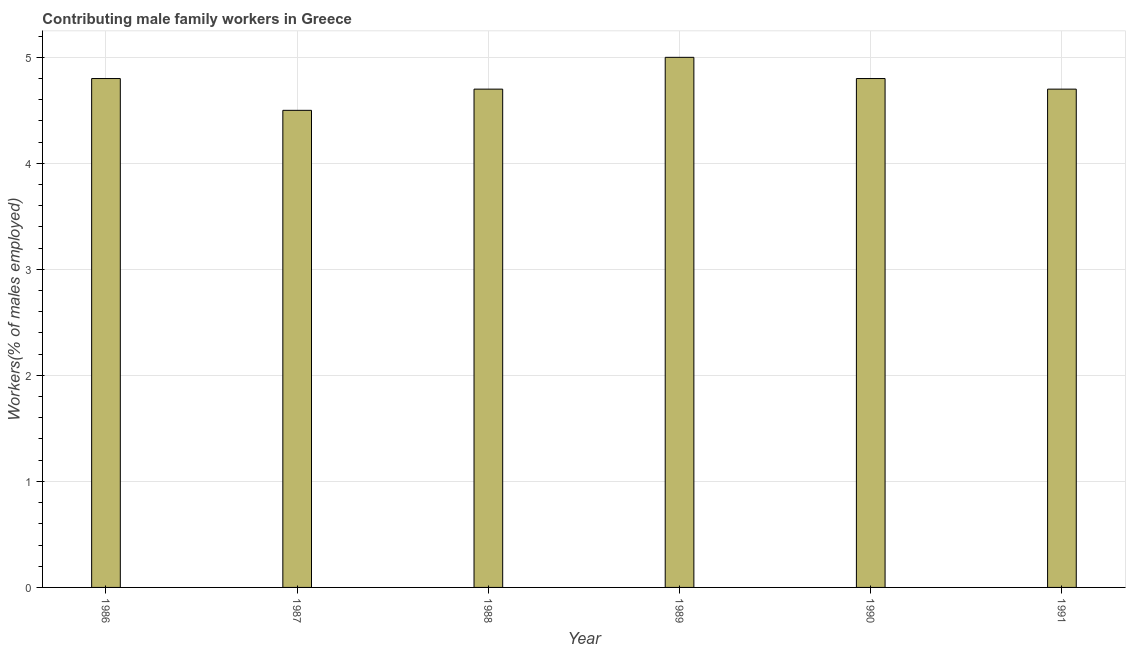What is the title of the graph?
Offer a terse response. Contributing male family workers in Greece. What is the label or title of the Y-axis?
Your answer should be compact. Workers(% of males employed). What is the contributing male family workers in 1988?
Offer a terse response. 4.7. Across all years, what is the maximum contributing male family workers?
Offer a terse response. 5. What is the sum of the contributing male family workers?
Make the answer very short. 28.5. What is the difference between the contributing male family workers in 1988 and 1991?
Provide a succinct answer. 0. What is the average contributing male family workers per year?
Provide a short and direct response. 4.75. What is the median contributing male family workers?
Your response must be concise. 4.75. In how many years, is the contributing male family workers greater than 3.6 %?
Keep it short and to the point. 6. Is the contributing male family workers in 1987 less than that in 1990?
Keep it short and to the point. Yes. Is the sum of the contributing male family workers in 1989 and 1991 greater than the maximum contributing male family workers across all years?
Offer a terse response. Yes. How many bars are there?
Provide a short and direct response. 6. Are all the bars in the graph horizontal?
Keep it short and to the point. No. What is the difference between two consecutive major ticks on the Y-axis?
Offer a very short reply. 1. Are the values on the major ticks of Y-axis written in scientific E-notation?
Keep it short and to the point. No. What is the Workers(% of males employed) in 1986?
Ensure brevity in your answer.  4.8. What is the Workers(% of males employed) in 1988?
Give a very brief answer. 4.7. What is the Workers(% of males employed) of 1990?
Ensure brevity in your answer.  4.8. What is the Workers(% of males employed) of 1991?
Offer a terse response. 4.7. What is the difference between the Workers(% of males employed) in 1986 and 1989?
Provide a succinct answer. -0.2. What is the difference between the Workers(% of males employed) in 1986 and 1991?
Keep it short and to the point. 0.1. What is the difference between the Workers(% of males employed) in 1987 and 1991?
Your response must be concise. -0.2. What is the difference between the Workers(% of males employed) in 1988 and 1989?
Ensure brevity in your answer.  -0.3. What is the difference between the Workers(% of males employed) in 1988 and 1991?
Your response must be concise. 0. What is the ratio of the Workers(% of males employed) in 1986 to that in 1987?
Your answer should be very brief. 1.07. What is the ratio of the Workers(% of males employed) in 1986 to that in 1988?
Make the answer very short. 1.02. What is the ratio of the Workers(% of males employed) in 1986 to that in 1989?
Offer a very short reply. 0.96. What is the ratio of the Workers(% of males employed) in 1987 to that in 1988?
Your response must be concise. 0.96. What is the ratio of the Workers(% of males employed) in 1987 to that in 1990?
Your answer should be very brief. 0.94. What is the ratio of the Workers(% of males employed) in 1988 to that in 1989?
Ensure brevity in your answer.  0.94. What is the ratio of the Workers(% of males employed) in 1988 to that in 1990?
Your answer should be very brief. 0.98. What is the ratio of the Workers(% of males employed) in 1988 to that in 1991?
Ensure brevity in your answer.  1. What is the ratio of the Workers(% of males employed) in 1989 to that in 1990?
Ensure brevity in your answer.  1.04. What is the ratio of the Workers(% of males employed) in 1989 to that in 1991?
Provide a succinct answer. 1.06. 